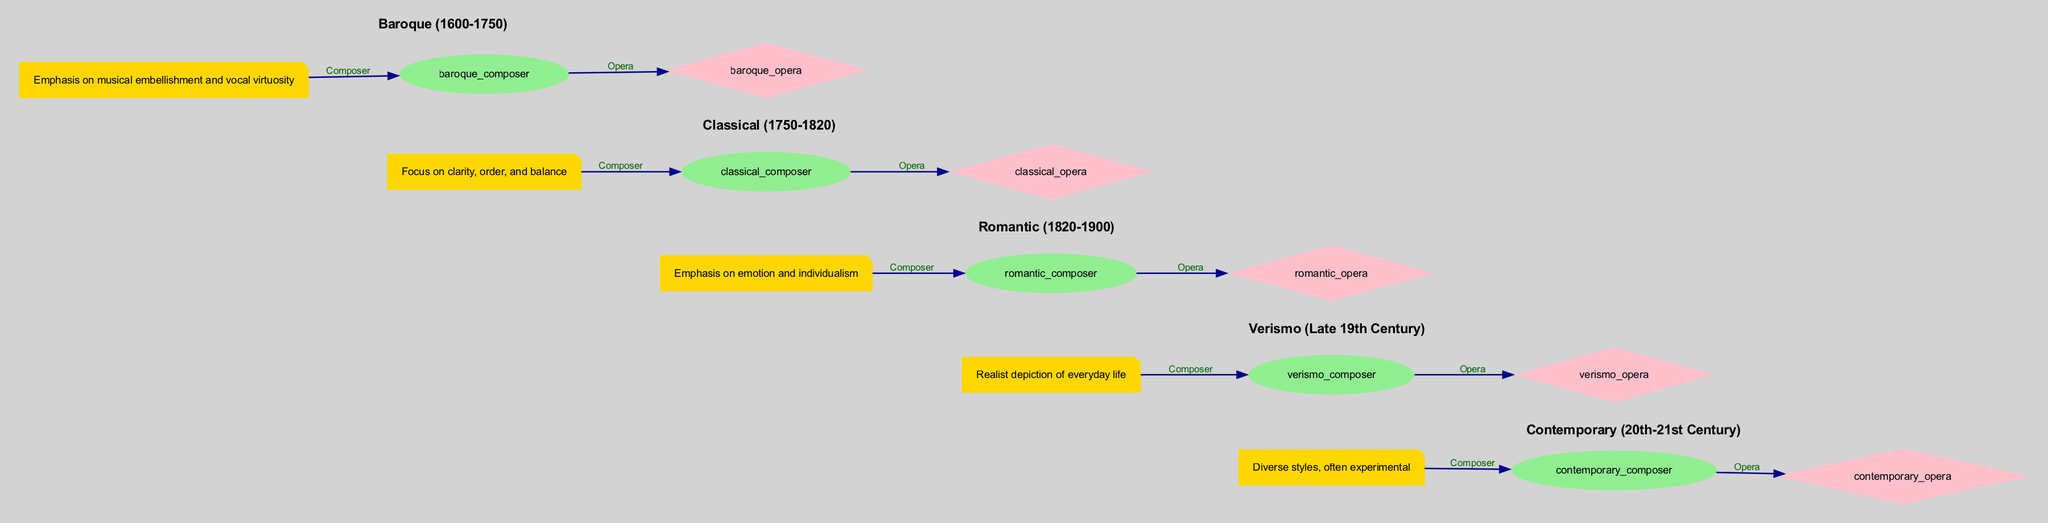What is the time period of the Baroque era? The diagram indicates that the Baroque era covers the years from 1600 to 1750. This information is directly stated in the description of the Baroque node.
Answer: 1600-1750 Who is the key composer of the Romantic era? The diagram identifies Giuseppe Verdi as the key composer during the Romantic era, shown in the node connected to the Romantic section.
Answer: Giuseppe Verdi What iconic opera is associated with Wolfgang Amadeus Mozart? The diagram links Mozart to his iconic opera, The Magic Flute, illustrated in the edge connecting the composer node to the opera node under the Classical section.
Answer: The Magic Flute Which opera represents the Verismo style? According to the diagram, La Bohème is the iconic opera that represents the Verismo style, as indicated by the connection from the verismo composer to the verismo opera.
Answer: La Bohème What is a common characteristic of the Contemporary opera style? The diagram notes that the Contemporary era is characterized by diverse styles and experimental approaches, clearly stated in its description.
Answer: Diverse styles, often experimental How many main opera styles are depicted in the diagram? Counting the different sections in the diagram reveals that there are five main opera styles: Baroque, Classical, Romantic, Verismo, and Contemporary. This is deduced by examining the different era nodes present in the diagram.
Answer: Five What does the edge label "Composer" indicate? The edge label "Composer" signifies the relationship between each era and its respective key composer, linking the era node to the composer node, providing a clear indication of their connection.
Answer: The relationship between era and composer Who composed Einstein on the Beach? Philip Glass is identified in the diagram as the key composer of the opera Einstein on the Beach, referenced in the Contemporary section leading to this opera node.
Answer: Philip Glass What is the emphasis of Romantic opera? The description in the Romantic era node specifies that the emphasis is on emotion and individualism, outlining the primary focus of operas from this time.
Answer: Emotion and individualism 